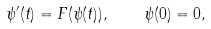Convert formula to latex. <formula><loc_0><loc_0><loc_500><loc_500>\psi ^ { \prime } ( t ) = F ( \psi ( t ) ) , \quad \psi ( 0 ) = 0 ,</formula> 